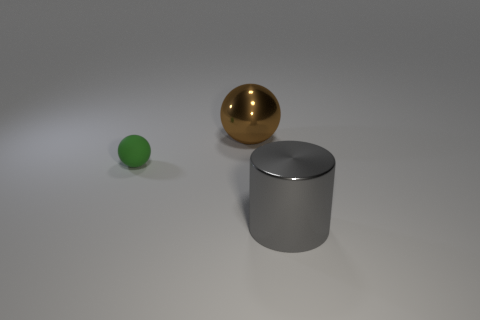Add 3 small green matte things. How many objects exist? 6 Subtract all balls. How many objects are left? 1 Add 3 shiny balls. How many shiny balls exist? 4 Subtract 0 yellow cylinders. How many objects are left? 3 Subtract all big brown shiny objects. Subtract all brown balls. How many objects are left? 1 Add 2 small matte spheres. How many small matte spheres are left? 3 